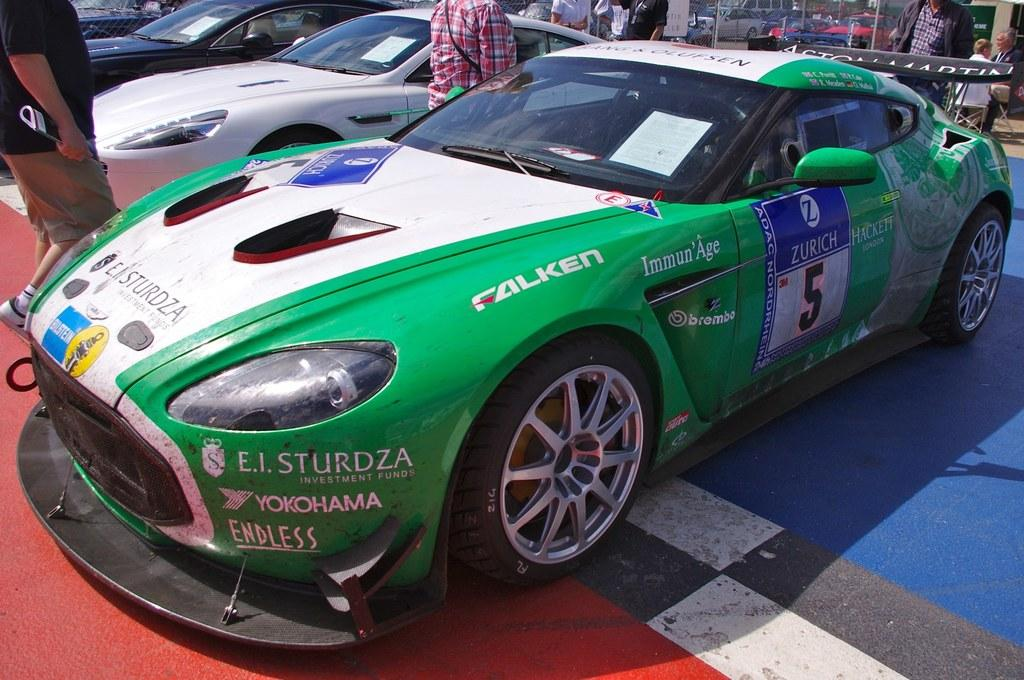What type of vehicles can be seen in the image? There are cars in the image. What are the people in the image doing? There are people standing on the road in the image. Can you describe the people in the background of the image? There are two people sitting on chairs in the background of the image. How many frogs are hopping on the cars in the image? There are no frogs present in the image, so it is not possible to determine how many might be hopping on the cars. 